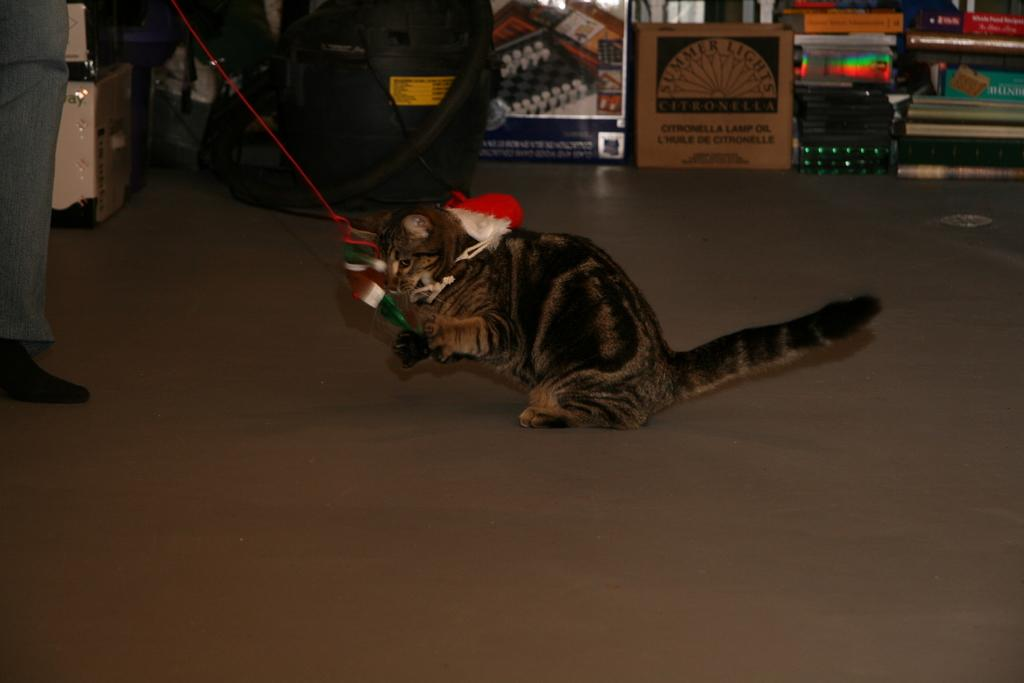What type of animal can be seen in the image? There is a cat in the image. Can you describe the person on the left side of the image? There is a person on the left side of the image, but no specific details are provided about their appearance or actions. What can be seen in the background of the image? There are objects in the background of the image, but no specific details are provided about them. What is visible at the bottom of the image? The floor is visible at the bottom of the image. What effect does the heat of summer have on the cat in the image? The image does not mention or depict any heat or summer conditions, so it is not possible to determine the effect on the cat. 